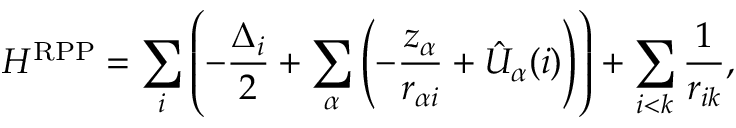Convert formula to latex. <formula><loc_0><loc_0><loc_500><loc_500>H ^ { R P P } = \sum _ { i } \left ( - \frac { \Delta _ { i } } { 2 } + \sum _ { \alpha } \left ( - \frac { z _ { \alpha } } { r _ { \alpha i } } + \hat { U } _ { \alpha } ( i ) \right ) \right ) + \sum _ { i < k } \frac { 1 } { r _ { i k } } ,</formula> 